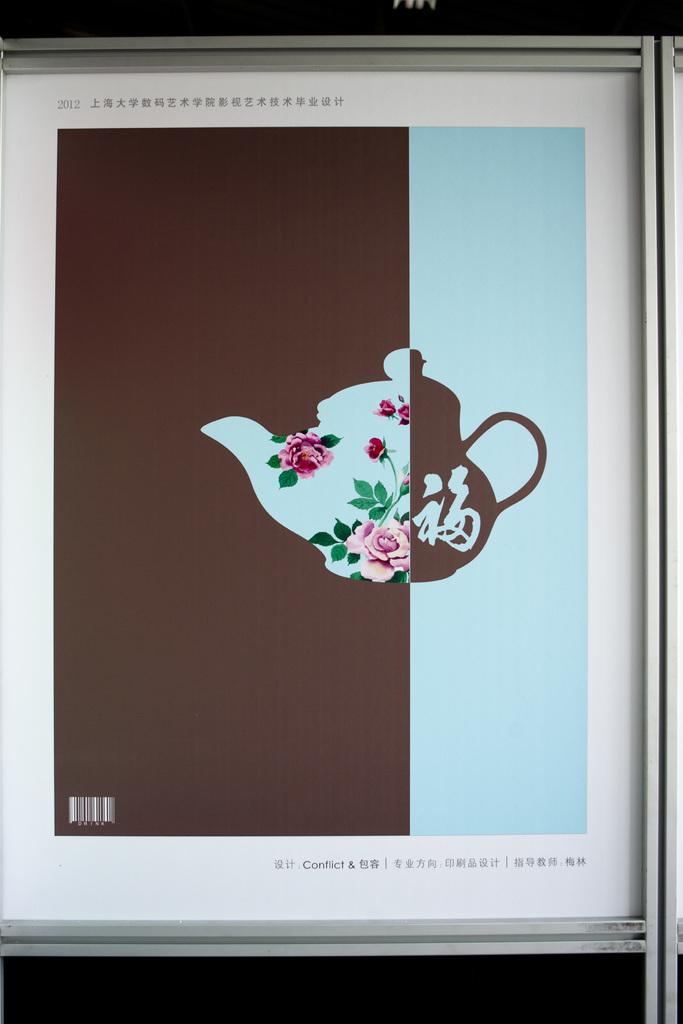What year is the print from?
Provide a succinct answer. 2012. What is the one english word at the bottom of this?
Your answer should be very brief. Conflict. 